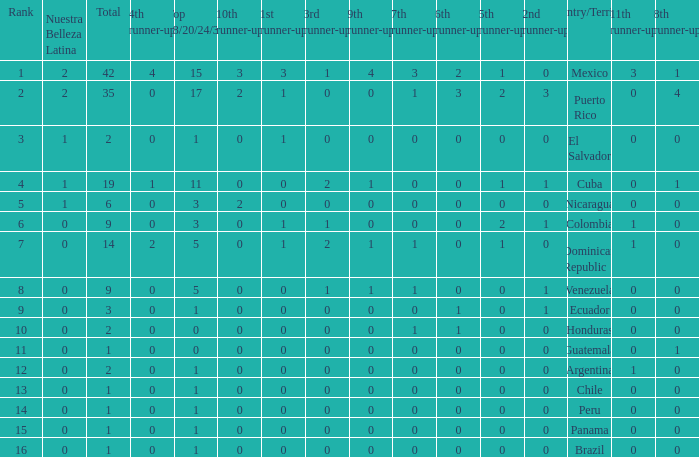What is the 7th runner-up of the country with a 10th runner-up greater than 0, a 9th runner-up greater than 0, and an 8th runner-up greater than 1? None. 